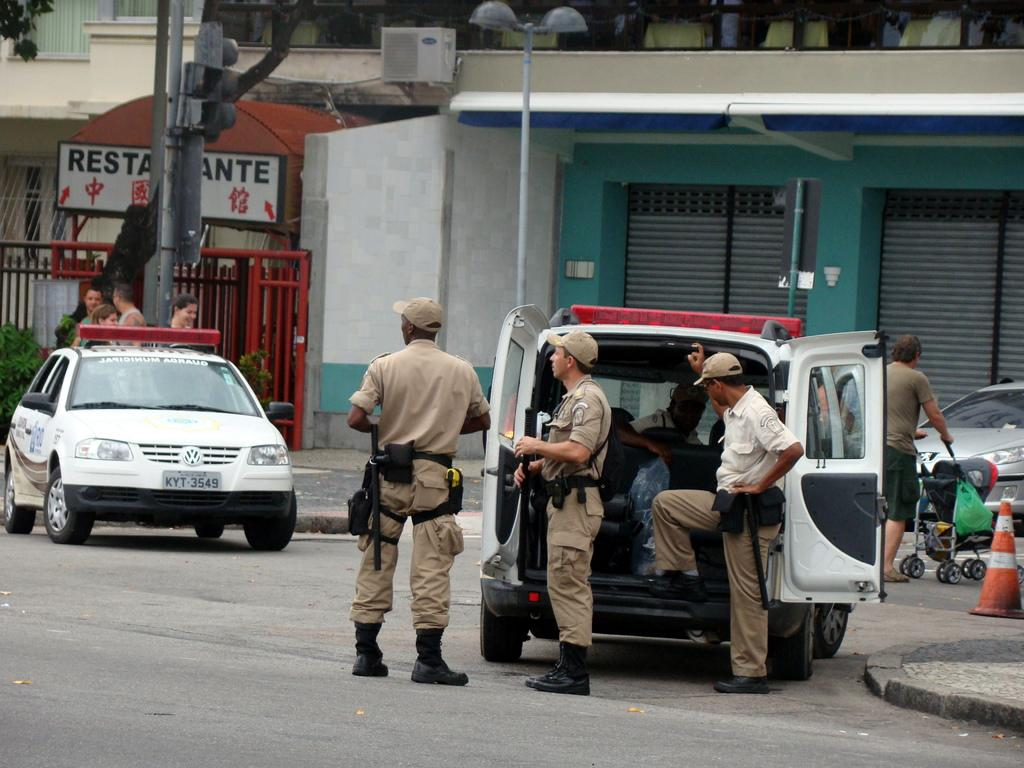Who or what can be seen in the image? There are people in the image. What else is present in the image besides people? There are vehicles, a building, a street light, and a traffic cone in the image. Can you see any ants carrying bones in the image? There are no ants or bones present in the image. Are there any trees visible in the image? There is no mention of trees in the provided facts, so we cannot determine if any are present in the image. 